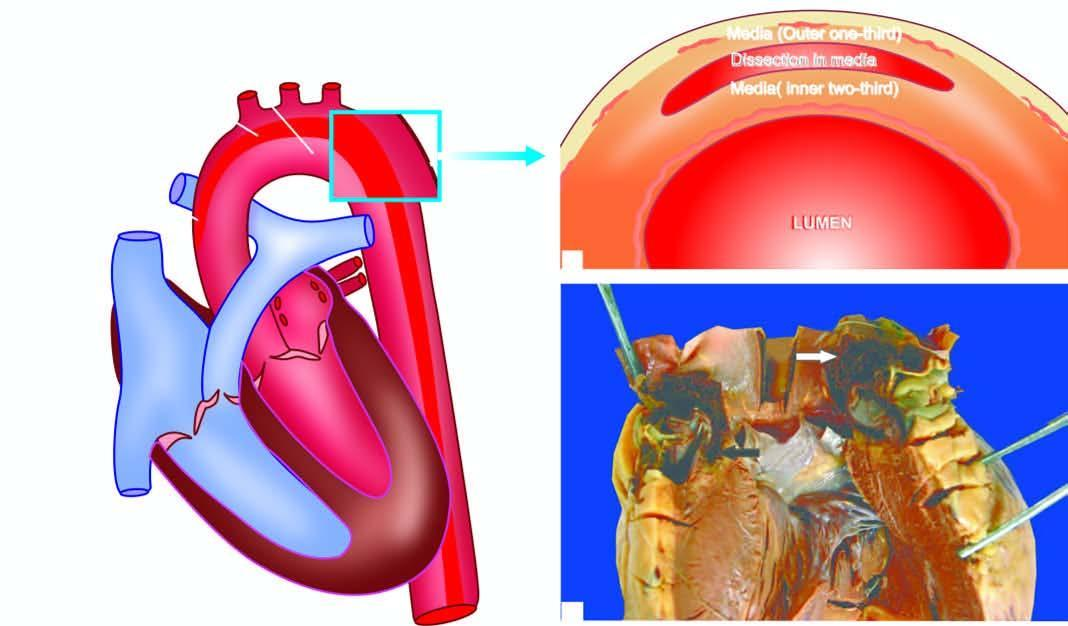does oxygen delivery tear in the aortic wall extend proximally upto aortic valve dissecting the media which contains clotted blood?
Answer the question using a single word or phrase. No 